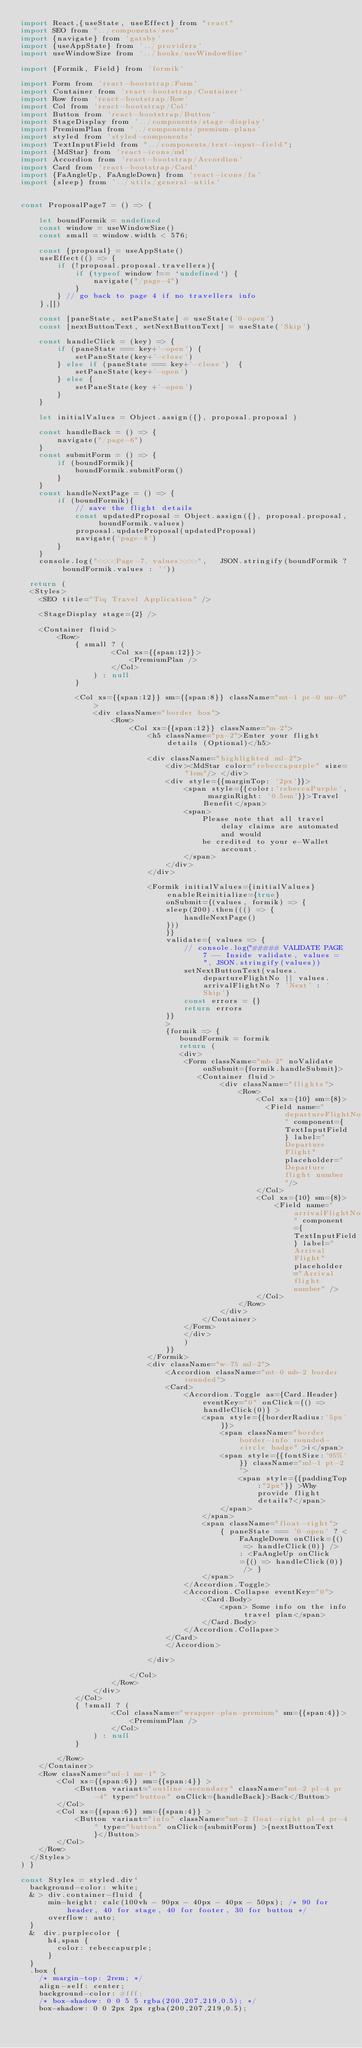<code> <loc_0><loc_0><loc_500><loc_500><_JavaScript_>import React,{useState, useEffect} from "react"
import SEO from "../components/seo"
import {navigate} from 'gatsby'
import {useAppState} from '../providers'
import useWindowSize from '../hooks/useWindowSize'

import {Formik, Field} from 'formik'

import Form from 'react-bootstrap/Form'
import Container from 'react-bootstrap/Container'
import Row from 'react-bootstrap/Row'
import Col from 'react-bootstrap/Col'
import Button from 'react-bootstrap/Button'
import StageDisplay from '../components/stage-display'
import PremiumPlan from '../components/premium-plans'
import styled from 'styled-components'
import TextInputField from "../components/text-input-field";
import {MdStar} from 'react-icons/md'
import Accordion from 'react-bootstrap/Accordion'
import Card from 'react-bootstrap/Card'
import {FaAngleUp, FaAngleDown} from 'react-icons/fa'
import {sleep} from '../utils/general-utils'


const ProposalPage7 = () => {

    let boundFormik = undefined
    const window = useWindowSize()
    const small = window.width < 576;

    const {proposal} = useAppState()
    useEffect(() => {
        if (!proposal.proposal.travellers){
            if (typeof window !== `undefined`) {
                navigate("/page-4")
            }
        } // go back to page 4 if no travellers info    
    },[])

    const [paneState, setPaneState] = useState('0-open')
    const [nextButtonText, setNextButtonText] = useState('Skip')

    const handleClick = (key) => {
        if (paneState === key+'-open') {
            setPaneState(key+'-close')
        } else if (paneState === key+'-close')  {
            setPaneState(key+'-open')
        } else {
            setPaneState(key +'-open')
        }
    }

    let initialValues = Object.assign({}, proposal.proposal )

    const handleBack = () => {
        navigate("/page-6")
    }
    const submitForm = () => {
        if (boundFormik){
            boundFormik.submitForm()
        }
    }
    const handleNextPage = () => {
        if (boundFormik){
            // save the flight details
            const updatedProposal = Object.assign({}, proposal.proposal, boundFormik.values)
            proposal.updateProposal(updatedProposal)
            navigate('page-8')
        }
    }
    console.log("<<<<Page-7, values>>>>",   JSON.stringify(boundFormik ? boundFormik.values : ''))

  return (
  <Styles>
    <SEO title="Tiq Travel Application" />
    
    <StageDisplay stage={2} />

    <Container fluid>
        <Row>
            { small ? (
                    <Col xs={{span:12}}>
                        <PremiumPlan />
                    </Col>
                ) : null
            }
            
            <Col xs={{span:12}} sm={{span:8}} className="mt-1 pr-0 mr-0">
                <div className="border box">
                    <Row>
                        <Col xs={{span:12}} className="m-2">
                            <h5 className="px-2">Enter your flight details (Optional)</h5>

                            <div className="highlighted ml-2">
                                <div><MdStar color="rebeccapurple" size="1em"/> </div>
                                <div style={{marginTop: '2px'}}>
                                    <span style={{color:'rebeccaPurple', marginRight: '0.5em'}}>Travel Benefit</span>
                                    <span>
                                        Please note that all travel delay claims are automated and would
                                        be credited to your e-Wallet account.
                                    </span>
                                </div>                                
                            </div>
                            
                            <Formik initialValues={initialValues} enableReinitialize={true}
                                onSubmit={(values, formik) => {
                                sleep(200).then((() => {
                                    handleNextPage()
                                }))
                                }}
                                validate={ values => {
                                    // console.log("##### VALIDATE PAGE 7 -- Inside validate, values = ", JSON.stringify(values))
                                    setNextButtonText(values.departureFlightNo || values.arrivalFlightNo ? 'Next' : 'Skip')
                                    const errors = {}
                                    return errors
                                }}      
                                >
                                {formik => { 
                                   boundFormik = formik
                                   return (
                                   <div>                                    
                                    <Form className="mb-2" noValidate onSubmit={formik.handleSubmit}>
                                       <Container fluid>
                                            <div className="flights">
                                                <Row>
                                                    <Col xs={10} sm={8}>
                                                      <Field name="departureFlightNo" component={TextInputField} label="Departure Flight" placeholder="Departure flight number"/>
                                                    </Col>
                                                    <Col xs={10} sm={8}>
                                                        <Field name="arrivalFlightNo" component={TextInputField} label="Arrival Flight" placeholder="Arrival flight number" />
                                                    </Col>                                  
                                                </Row>                                  
                                            </div>
                                        </Container>
                                    </Form>
                                    </div>
                                    )
                                }}
                            </Formik>
                            <div className="w-75 ml-2">
                                <Accordion className="mt-0 mb-2 border rounded">
                                <Card>
                                    <Accordion.Toggle as={Card.Header} eventKey="0" onClick={() => handleClick(0)} >
                                        <span style={{borderRadius:'5px'}}>
                                            <span className="border border-info rounded-circle badge" >i</span>
                                            <span style={{fontSize:'95%'}} className="ml-1 pt-2">
                                                <span style={{paddingTop:"2px"}} >Why provide flight details?</span>
                                            </span>
                                        </span>
                                        <span className="float-right">
                                            { paneState === '0-open' ? <FaAngleDown onClick={() => handleClick(0)} /> : <FaAngleUp onClick={() => handleClick(0)} /> }
                                        </span>
                                    </Accordion.Toggle>
                                    <Accordion.Collapse eventKey="0">
                                        <Card.Body>
                                            <span> Some info on the info travel plan</span>
                                        </Card.Body>
                                    </Accordion.Collapse>
                                </Card>
                                </Accordion>

                            </div>

                        </Col>
                    </Row>
                </div>
            </Col>
            { !small ? (
                    <Col className="wrapper-plan-premium" sm={{span:4}}>
                        <PremiumPlan />
                    </Col>
                ) : null
            }

        </Row>        
    </Container>
    <Row className="ml-1 mr-1" >
        <Col xs={{span:6}} sm={{span:4}} >
            <Button variant="outline-secondary" className="mt-2 pl-4 pr-4" type="button" onClick={handleBack}>Back</Button>
        </Col>
        <Col xs={{span:6}} sm={{span:4}} >
            <Button variant="info" className="mt-2 float-right pl-4 pr-4" type="button" onClick={submitForm} >{nextButtonText}</Button>
        </Col>
    </Row>
  </Styles>
) } 

const Styles = styled.div`
  background-color: white;
  & > div.container-fluid {
      min-height: calc(100vh - 90px - 40px - 40px - 50px); /* 90 for header, 40 for stage, 40 for footer, 30 for button */
      overflow: auto;
  }
  &  div.purplecolor {
      h4,span {
        color: rebeccapurple;
      }
  }
  .box {
    /* margin-top: 2rem; */
    align-self: center;
    background-color: #fff;
    /* box-shadow: 0 0 5 5 rgba(200,207,219,0.5); */
    box-shadow: 0 0 2px 2px rgba(200,207,219,0.5);</code> 